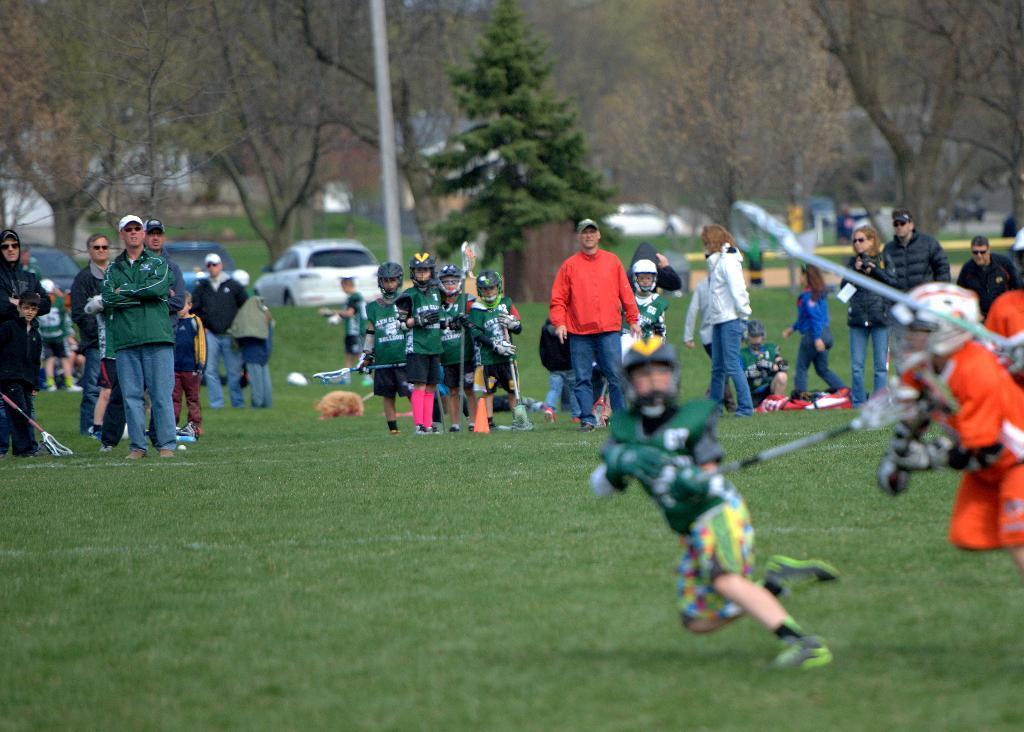Could you give a brief overview of what you see in this image? In this image, there are a few people. We can see the ground with some objects. We can also see some grass and trees. We can see a pole. There are a few vehicles. We can also see a white colored object. 